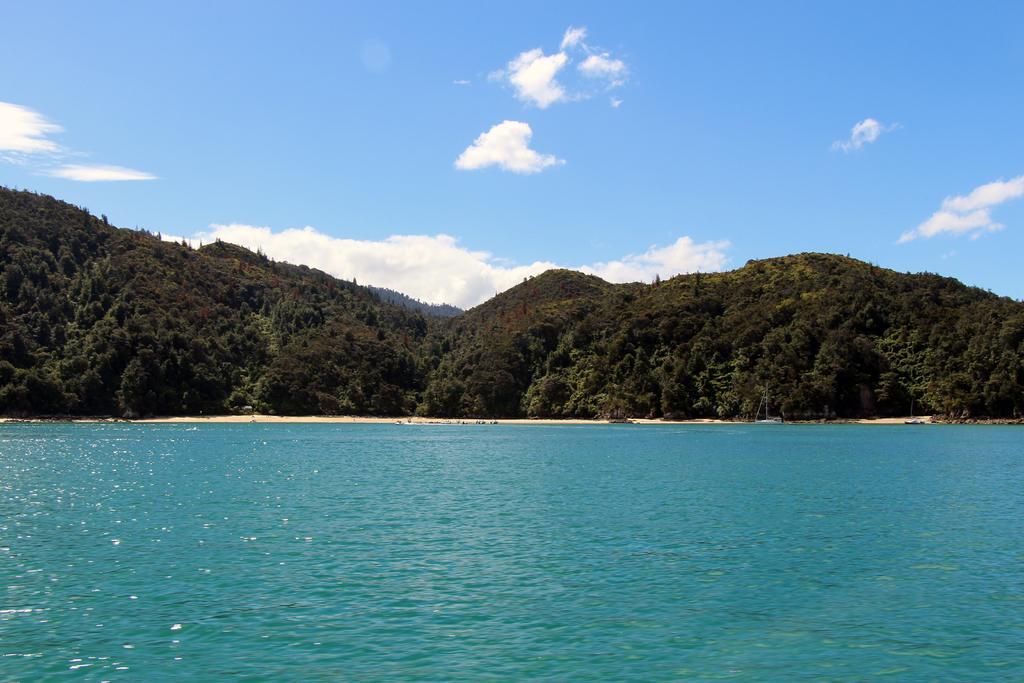Could you give a brief overview of what you see in this image? In this image we can see an ocean, beach and forest. The sky is blue with some clouds. 